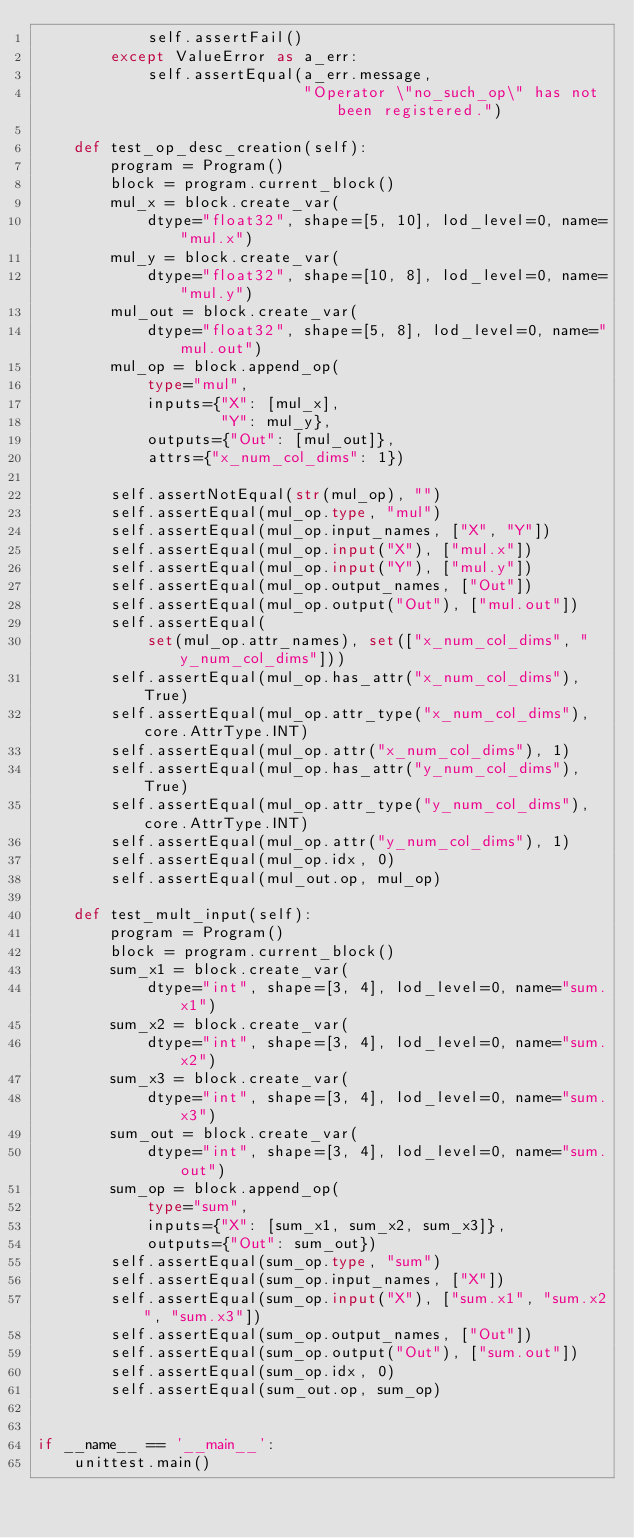Convert code to text. <code><loc_0><loc_0><loc_500><loc_500><_Python_>            self.assertFail()
        except ValueError as a_err:
            self.assertEqual(a_err.message,
                             "Operator \"no_such_op\" has not been registered.")

    def test_op_desc_creation(self):
        program = Program()
        block = program.current_block()
        mul_x = block.create_var(
            dtype="float32", shape=[5, 10], lod_level=0, name="mul.x")
        mul_y = block.create_var(
            dtype="float32", shape=[10, 8], lod_level=0, name="mul.y")
        mul_out = block.create_var(
            dtype="float32", shape=[5, 8], lod_level=0, name="mul.out")
        mul_op = block.append_op(
            type="mul",
            inputs={"X": [mul_x],
                    "Y": mul_y},
            outputs={"Out": [mul_out]},
            attrs={"x_num_col_dims": 1})

        self.assertNotEqual(str(mul_op), "")
        self.assertEqual(mul_op.type, "mul")
        self.assertEqual(mul_op.input_names, ["X", "Y"])
        self.assertEqual(mul_op.input("X"), ["mul.x"])
        self.assertEqual(mul_op.input("Y"), ["mul.y"])
        self.assertEqual(mul_op.output_names, ["Out"])
        self.assertEqual(mul_op.output("Out"), ["mul.out"])
        self.assertEqual(
            set(mul_op.attr_names), set(["x_num_col_dims", "y_num_col_dims"]))
        self.assertEqual(mul_op.has_attr("x_num_col_dims"), True)
        self.assertEqual(mul_op.attr_type("x_num_col_dims"), core.AttrType.INT)
        self.assertEqual(mul_op.attr("x_num_col_dims"), 1)
        self.assertEqual(mul_op.has_attr("y_num_col_dims"), True)
        self.assertEqual(mul_op.attr_type("y_num_col_dims"), core.AttrType.INT)
        self.assertEqual(mul_op.attr("y_num_col_dims"), 1)
        self.assertEqual(mul_op.idx, 0)
        self.assertEqual(mul_out.op, mul_op)

    def test_mult_input(self):
        program = Program()
        block = program.current_block()
        sum_x1 = block.create_var(
            dtype="int", shape=[3, 4], lod_level=0, name="sum.x1")
        sum_x2 = block.create_var(
            dtype="int", shape=[3, 4], lod_level=0, name="sum.x2")
        sum_x3 = block.create_var(
            dtype="int", shape=[3, 4], lod_level=0, name="sum.x3")
        sum_out = block.create_var(
            dtype="int", shape=[3, 4], lod_level=0, name="sum.out")
        sum_op = block.append_op(
            type="sum",
            inputs={"X": [sum_x1, sum_x2, sum_x3]},
            outputs={"Out": sum_out})
        self.assertEqual(sum_op.type, "sum")
        self.assertEqual(sum_op.input_names, ["X"])
        self.assertEqual(sum_op.input("X"), ["sum.x1", "sum.x2", "sum.x3"])
        self.assertEqual(sum_op.output_names, ["Out"])
        self.assertEqual(sum_op.output("Out"), ["sum.out"])
        self.assertEqual(sum_op.idx, 0)
        self.assertEqual(sum_out.op, sum_op)


if __name__ == '__main__':
    unittest.main()
</code> 